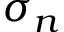<formula> <loc_0><loc_0><loc_500><loc_500>\sigma _ { n }</formula> 